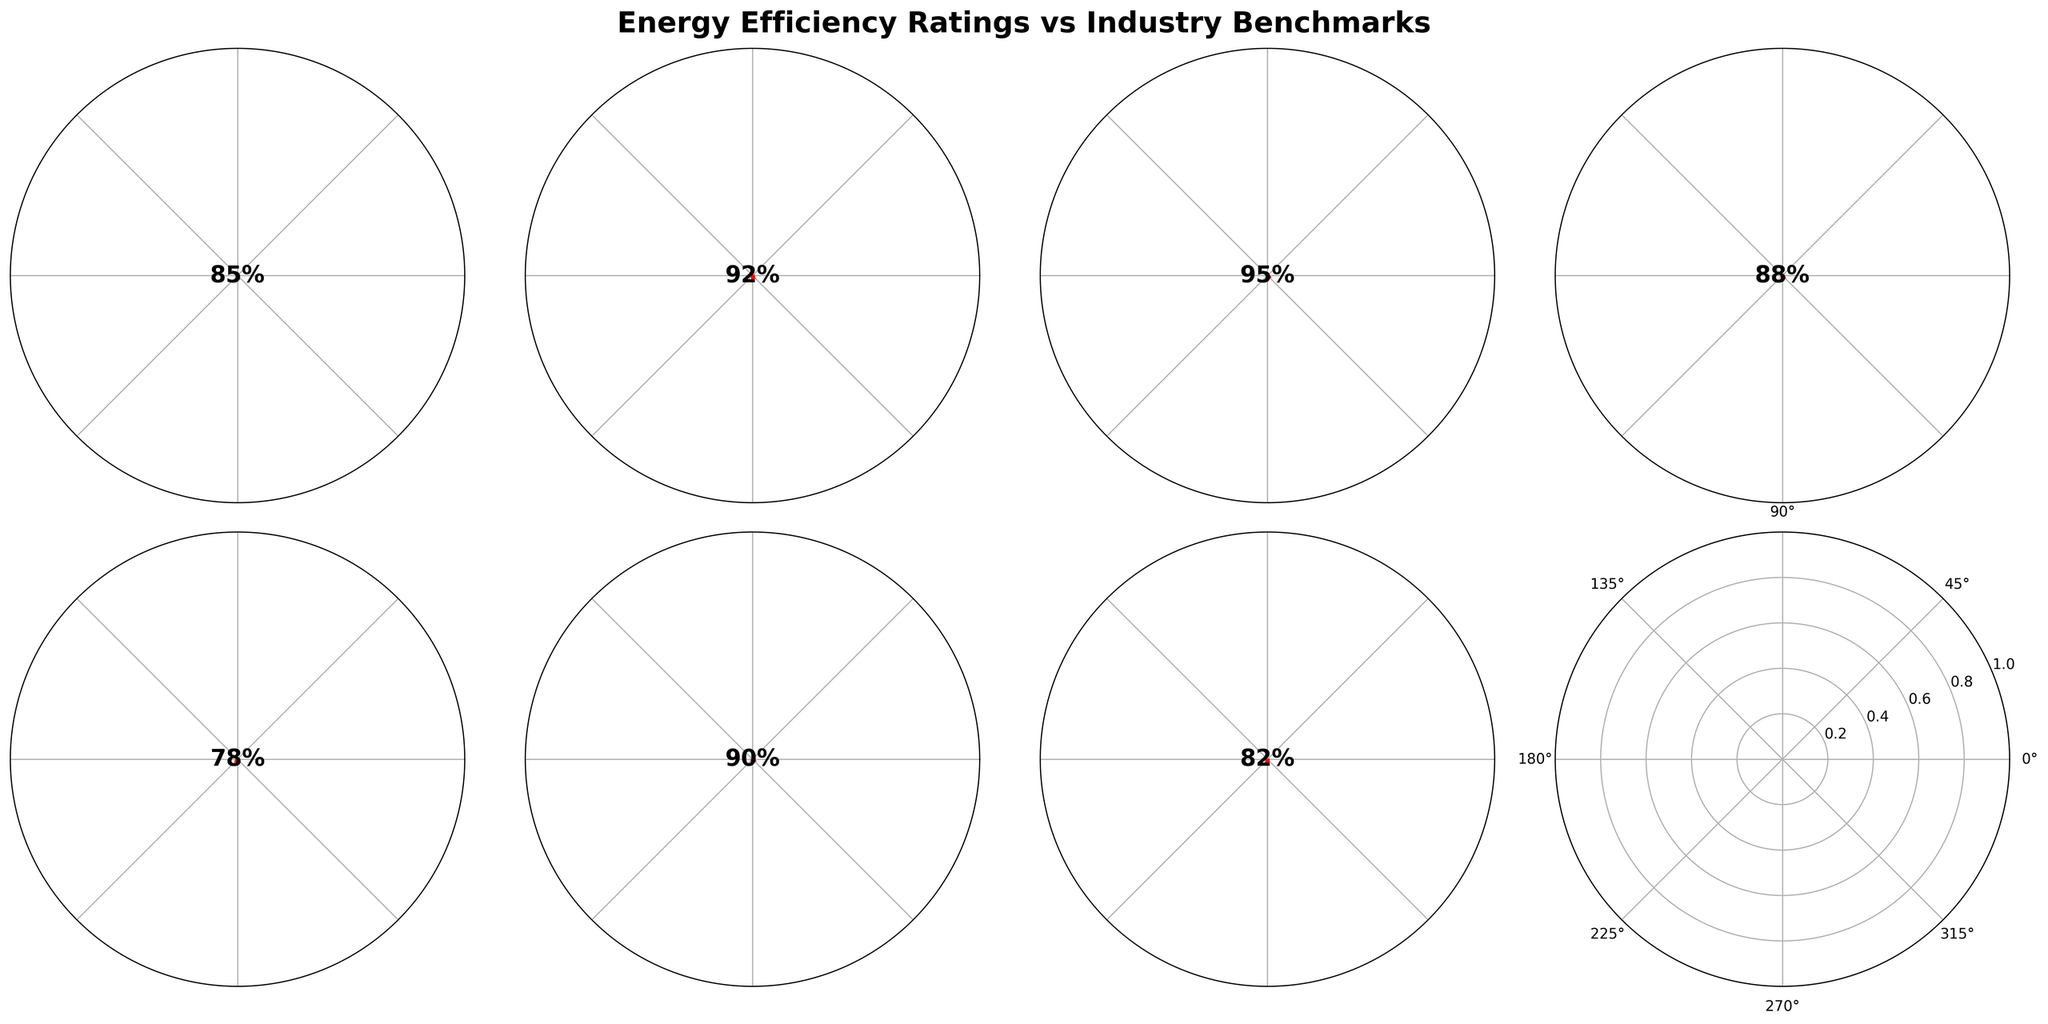Which system has the highest energy efficiency rating? By examining each gauge chart and identifying the highest value on the scales, we can see that the LED Lighting System has an energy efficiency rating of 95%.
Answer: LED Lighting System Is there any system with an efficiency rating lower than its benchmark? We need to compare the efficiency rating with the benchmark for each system. The Energy Recovery Ventilator has an efficiency rating of 78%, which is higher than its benchmark of 70%. Therefore, no system has an efficiency rating lower than its benchmark.
Answer: No How much higher is the benchmark for the Building Insulation system compared to the Energy Recovery Ventilator system? The benchmark for Building Insulation is 85%, and for Energy Recovery Ventilator, it is 70%. The difference is calculated as 85% - 70% = 15%.
Answer: 15% Which system's efficiency rating is closest to its benchmark? By calculating the difference between the efficiency rating and the benchmark for each system, we find: HVAC System: 85% - 75% = 10%, Solar Panel Array: 92% - 80% = 12%, LED Lighting System: 95% - 85% = 10%, Smart Thermostat: 88% - 82% = 6%, Energy Recovery Ventilator: 78% - 70% = 8%, Building Insulation: 90% - 85% = 5%, Window Glazing: 82% - 75% = 7%. The Building Insulation system has the smallest difference, which is 5%.
Answer: Building Insulation What is the average efficiency rating of the systems? To find the average, sum all the efficiency ratings and divide by the number of systems. (85 + 92 + 95 + 88 + 78 + 90 + 82) / 7 = 610 / 7 ≈ 87.14%.
Answer: 87.14% Which system has the widest gap between its efficiency rating and the benchmark? Calculating the differences, we find: HVAC System: 10%, Solar Panel Array: 12%, LED Lighting System: 10%, Smart Thermostat: 6%, Energy Recovery Ventilator: 8%, Building Insulation: 5%, Window Glazing: 7%. The Solar Panel Array has the widest gap of 12%.
Answer: Solar Panel Array How many systems have a benchmark equal to or above 80%? By examining the benchmarks: HVAC System: 75%, Solar Panel Array: 80%, LED Lighting System: 85%, Smart Thermostat: 82%, Energy Recovery Ventilator: 70%, Building Insulation: 85%, Window Glazing: 75%. Four systems have benchmarks equal to or above 80% (Solar Panel Array, LED Lighting System, Smart Thermostat, Building Insulation).
Answer: 4 If we rank the systems by their efficiency ratings, which system takes the third place? By sorting the systems by their efficiency ratings in descending order: LED Lighting System (95%), Solar Panel Array (92%), Building Insulation (90%), Smart Thermostat (88%), HVAC System (85%), Window Glazing (82%), Energy Recovery Ventilator (78%). The Building Insulation is the third highest.
Answer: Building Insulation Does the Smart Thermostat exceed its industry benchmark by more than 5%? The efficiency rating for the Smart Thermostat is 88% and its benchmark is 82%. The difference is 88% - 82% = 6%, which is more than 5%.
Answer: Yes 